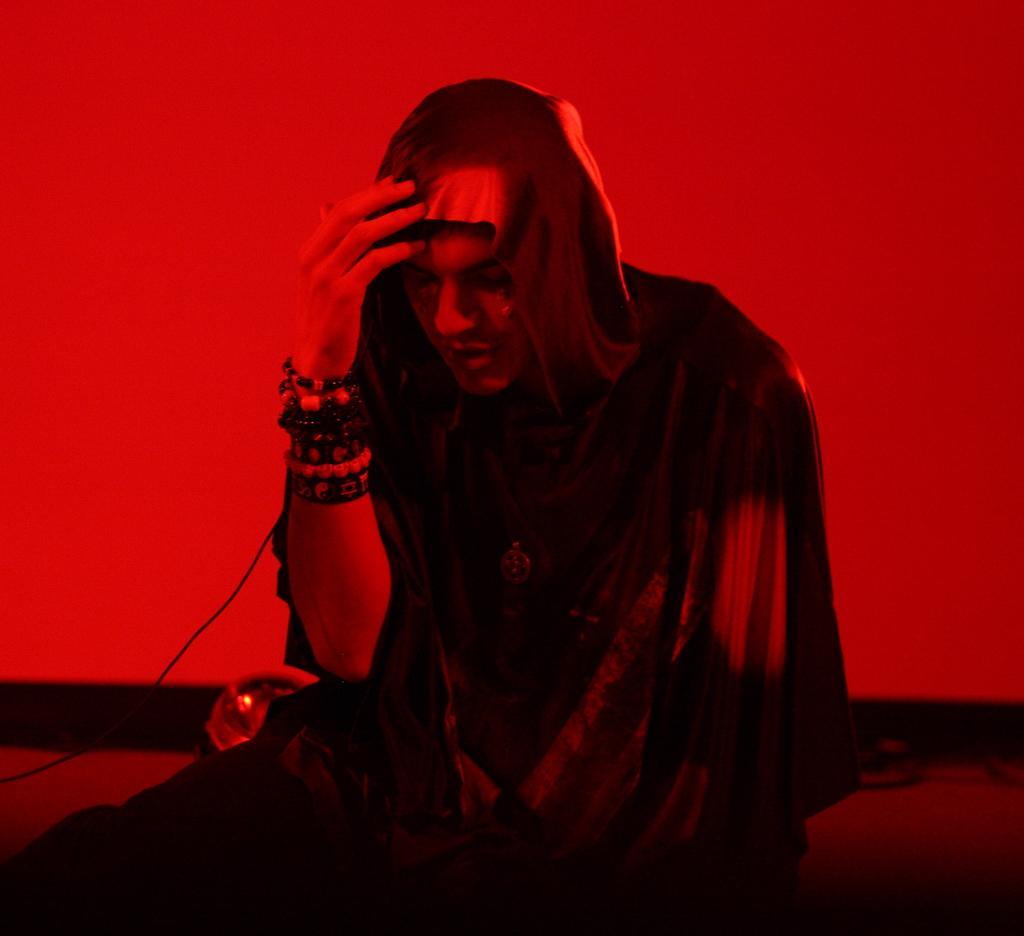Please provide a concise description of this image. This image is taken indoors. In this image the background is red in color and there is a wall. In the middle of the image a man is sitting on the floor. At the bottom of the image there is a floor. 